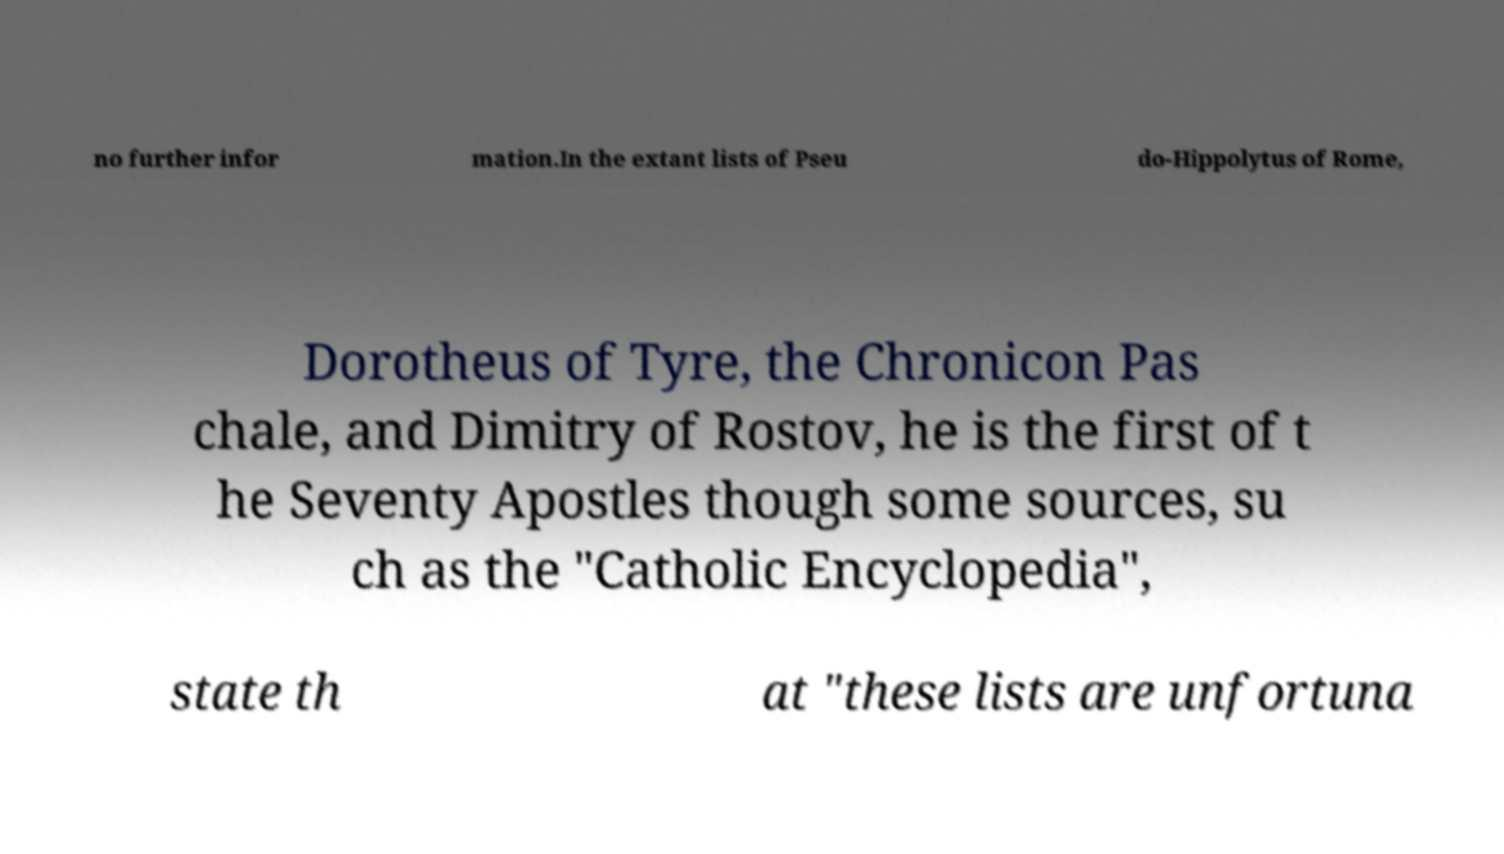Could you extract and type out the text from this image? no further infor mation.In the extant lists of Pseu do-Hippolytus of Rome, Dorotheus of Tyre, the Chronicon Pas chale, and Dimitry of Rostov, he is the first of t he Seventy Apostles though some sources, su ch as the "Catholic Encyclopedia", state th at "these lists are unfortuna 